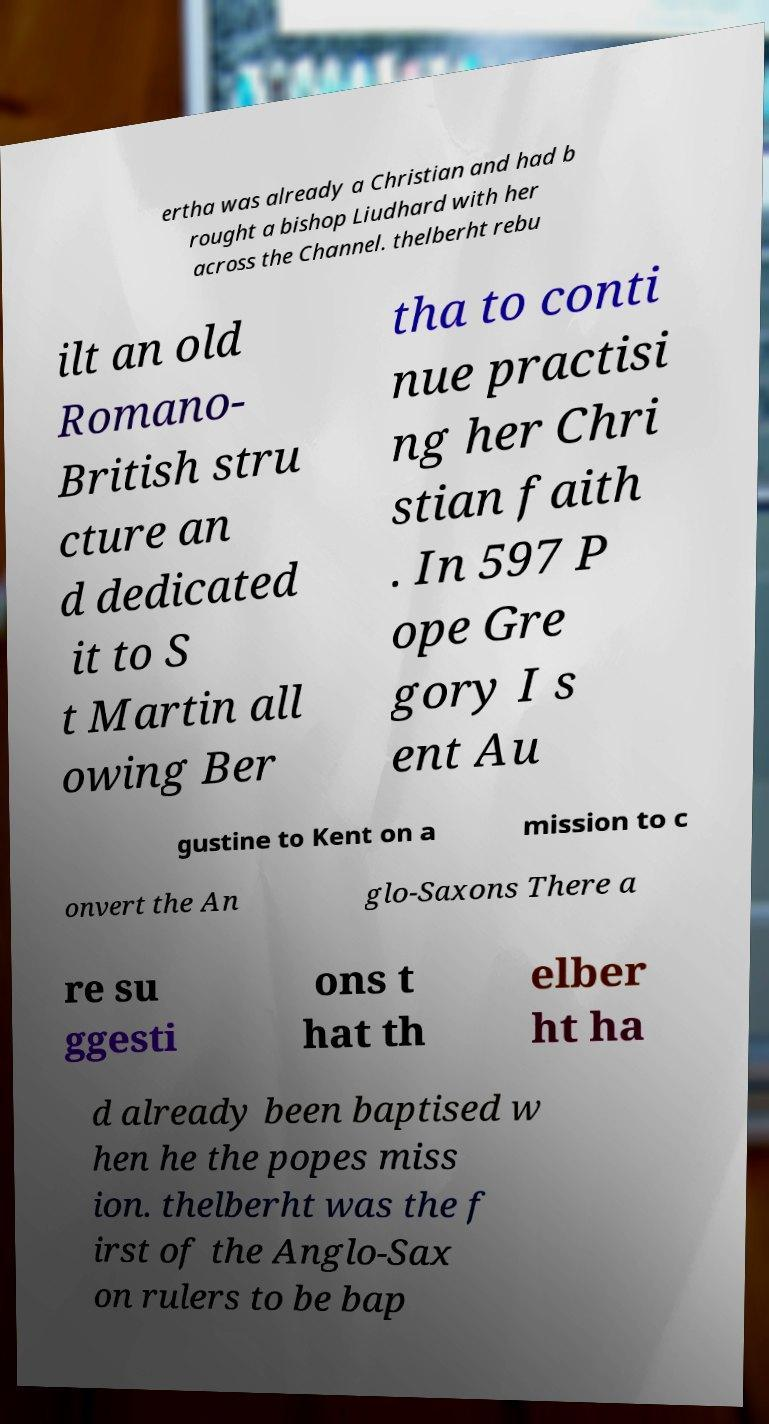Could you extract and type out the text from this image? ertha was already a Christian and had b rought a bishop Liudhard with her across the Channel. thelberht rebu ilt an old Romano- British stru cture an d dedicated it to S t Martin all owing Ber tha to conti nue practisi ng her Chri stian faith . In 597 P ope Gre gory I s ent Au gustine to Kent on a mission to c onvert the An glo-Saxons There a re su ggesti ons t hat th elber ht ha d already been baptised w hen he the popes miss ion. thelberht was the f irst of the Anglo-Sax on rulers to be bap 